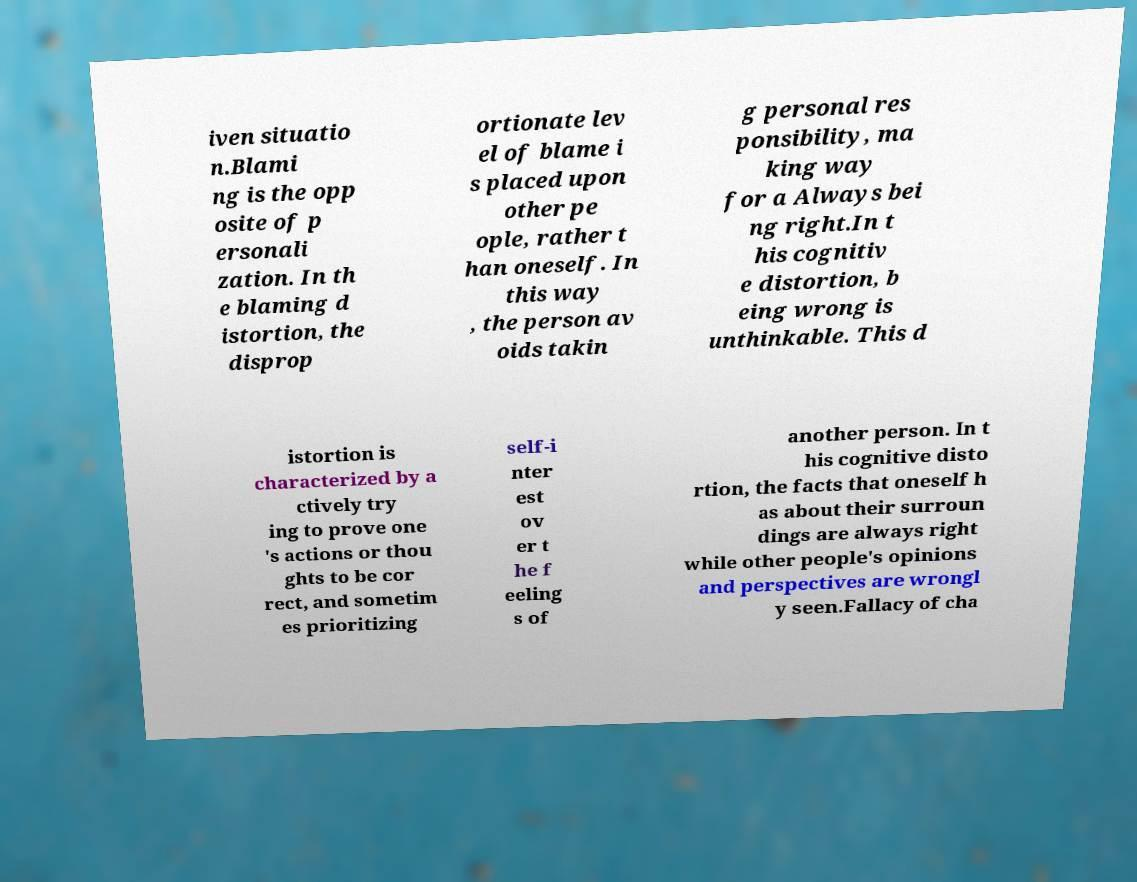Please read and relay the text visible in this image. What does it say? iven situatio n.Blami ng is the opp osite of p ersonali zation. In th e blaming d istortion, the disprop ortionate lev el of blame i s placed upon other pe ople, rather t han oneself. In this way , the person av oids takin g personal res ponsibility, ma king way for a Always bei ng right.In t his cognitiv e distortion, b eing wrong is unthinkable. This d istortion is characterized by a ctively try ing to prove one 's actions or thou ghts to be cor rect, and sometim es prioritizing self-i nter est ov er t he f eeling s of another person. In t his cognitive disto rtion, the facts that oneself h as about their surroun dings are always right while other people's opinions and perspectives are wrongl y seen.Fallacy of cha 